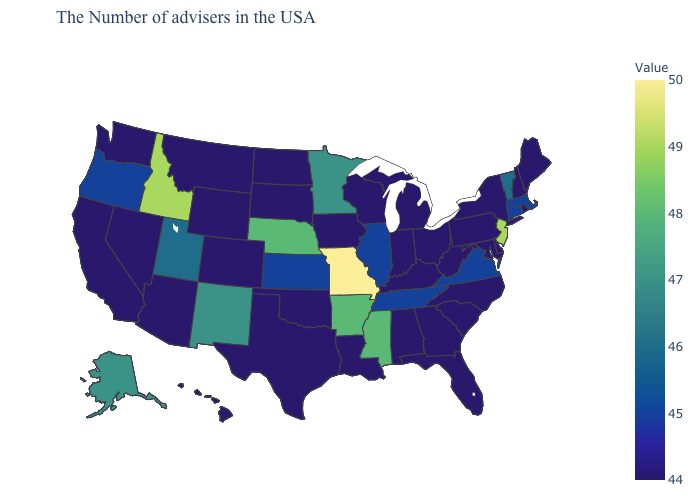Does Missouri have the highest value in the USA?
Keep it brief. Yes. Is the legend a continuous bar?
Write a very short answer. Yes. Which states hav the highest value in the Northeast?
Answer briefly. New Jersey. Does Missouri have the highest value in the USA?
Write a very short answer. Yes. Which states have the lowest value in the Northeast?
Short answer required. Maine, Rhode Island, New Hampshire, New York, Pennsylvania. Does Indiana have the highest value in the MidWest?
Quick response, please. No. 